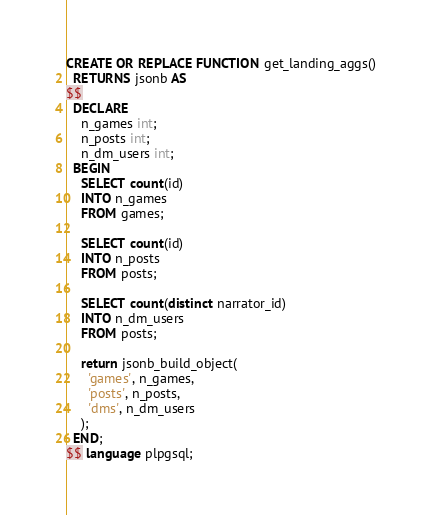<code> <loc_0><loc_0><loc_500><loc_500><_SQL_>CREATE OR REPLACE FUNCTION get_landing_aggs()
  RETURNS jsonb AS
$$
  DECLARE
    n_games int;
    n_posts int;
    n_dm_users int;
  BEGIN
    SELECT count(id)
    INTO n_games
    FROM games;

    SELECT count(id)
    INTO n_posts
    FROM posts;

    SELECT count(distinct narrator_id)
    INTO n_dm_users
    FROM posts;

    return jsonb_build_object(
      'games', n_games,
      'posts', n_posts,
      'dms', n_dm_users
    );
  END;
$$ language plpgsql;</code> 